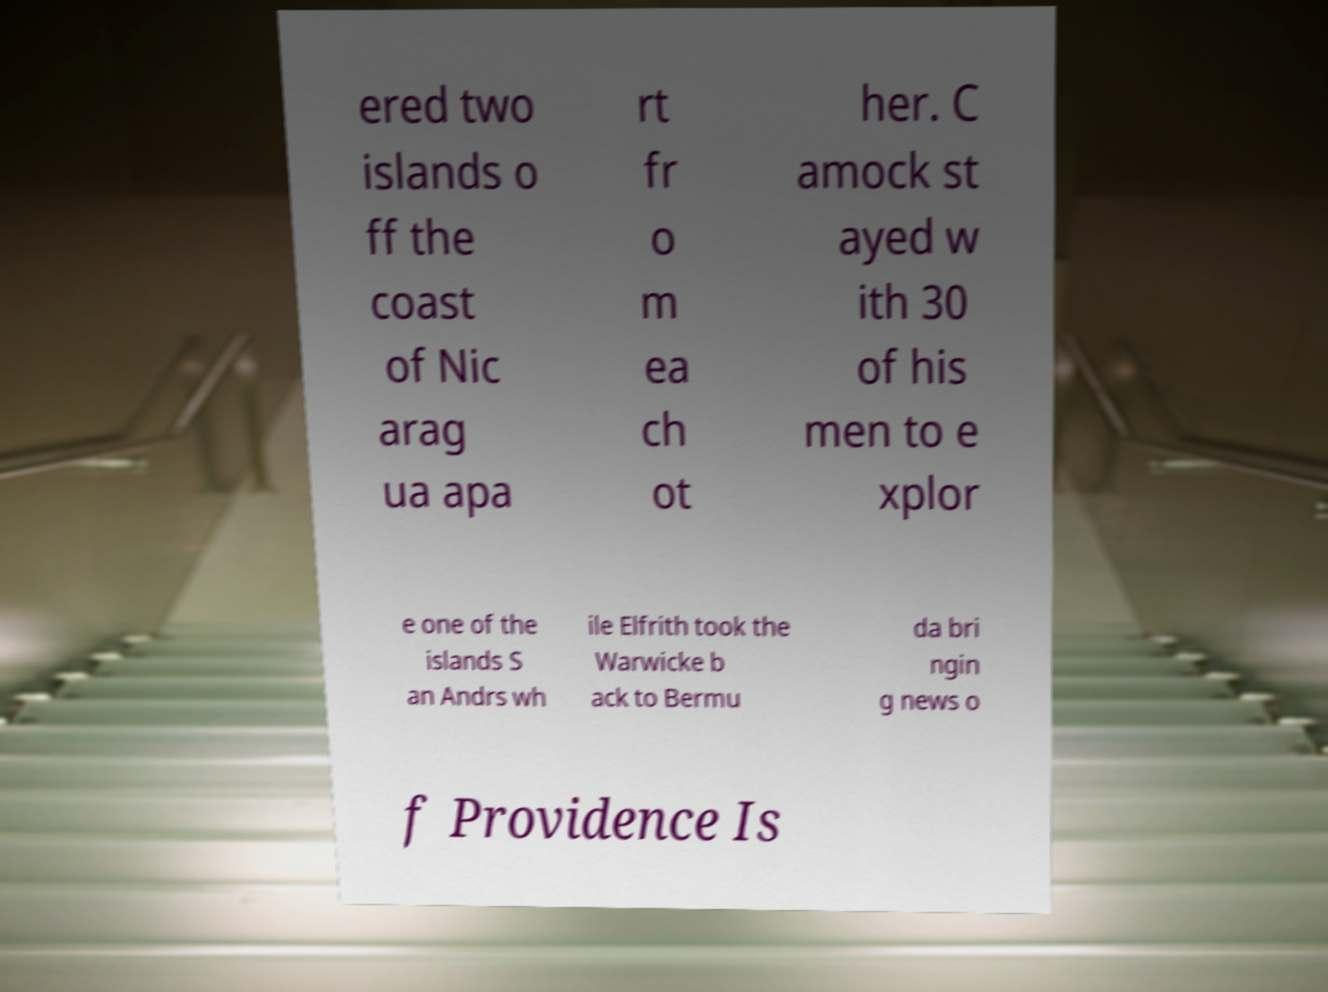Could you assist in decoding the text presented in this image and type it out clearly? ered two islands o ff the coast of Nic arag ua apa rt fr o m ea ch ot her. C amock st ayed w ith 30 of his men to e xplor e one of the islands S an Andrs wh ile Elfrith took the Warwicke b ack to Bermu da bri ngin g news o f Providence Is 